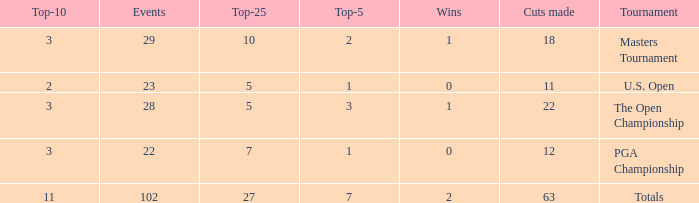How many top 10s associated with 3 top 5s and under 22 cuts made? None. 